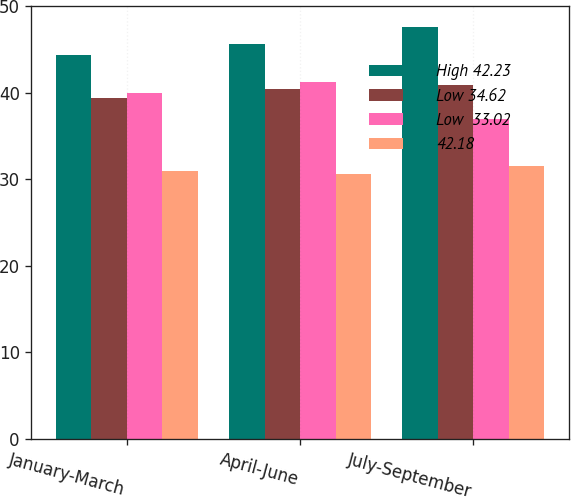<chart> <loc_0><loc_0><loc_500><loc_500><stacked_bar_chart><ecel><fcel>January-March<fcel>April-June<fcel>July-September<nl><fcel>High 42.23<fcel>44.35<fcel>45.6<fcel>47.65<nl><fcel>Low 34.62<fcel>39.38<fcel>40.48<fcel>40.95<nl><fcel>Low  33.02<fcel>39.94<fcel>41.24<fcel>36.99<nl><fcel>42.18<fcel>31<fcel>30.56<fcel>31.59<nl></chart> 